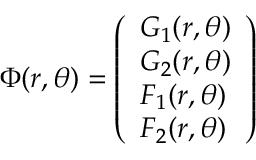Convert formula to latex. <formula><loc_0><loc_0><loc_500><loc_500>\Phi ( r , \theta ) = \left ( \begin{array} { l } { G _ { 1 } ( r , \theta ) } \\ { G _ { 2 } ( r , \theta ) } \\ { F _ { 1 } ( r , \theta ) } \\ { F _ { 2 } ( r , \theta ) } \end{array} \right )</formula> 